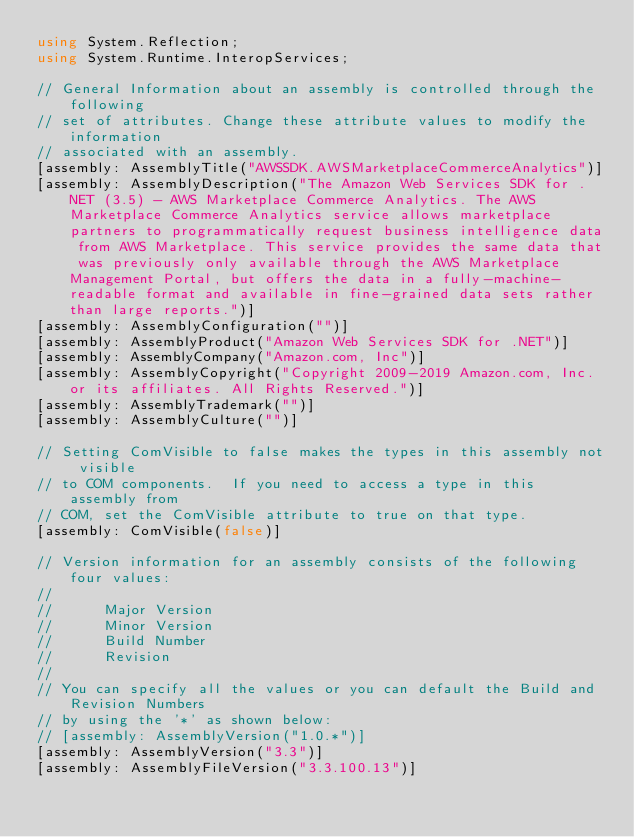<code> <loc_0><loc_0><loc_500><loc_500><_C#_>using System.Reflection;
using System.Runtime.InteropServices;

// General Information about an assembly is controlled through the following 
// set of attributes. Change these attribute values to modify the information
// associated with an assembly.
[assembly: AssemblyTitle("AWSSDK.AWSMarketplaceCommerceAnalytics")]
[assembly: AssemblyDescription("The Amazon Web Services SDK for .NET (3.5) - AWS Marketplace Commerce Analytics. The AWS Marketplace Commerce Analytics service allows marketplace partners to programmatically request business intelligence data from AWS Marketplace. This service provides the same data that was previously only available through the AWS Marketplace Management Portal, but offers the data in a fully-machine-readable format and available in fine-grained data sets rather than large reports.")]
[assembly: AssemblyConfiguration("")]
[assembly: AssemblyProduct("Amazon Web Services SDK for .NET")]
[assembly: AssemblyCompany("Amazon.com, Inc")]
[assembly: AssemblyCopyright("Copyright 2009-2019 Amazon.com, Inc. or its affiliates. All Rights Reserved.")]
[assembly: AssemblyTrademark("")]
[assembly: AssemblyCulture("")]

// Setting ComVisible to false makes the types in this assembly not visible 
// to COM components.  If you need to access a type in this assembly from 
// COM, set the ComVisible attribute to true on that type.
[assembly: ComVisible(false)]

// Version information for an assembly consists of the following four values:
//
//      Major Version
//      Minor Version 
//      Build Number
//      Revision
//
// You can specify all the values or you can default the Build and Revision Numbers 
// by using the '*' as shown below:
// [assembly: AssemblyVersion("1.0.*")]
[assembly: AssemblyVersion("3.3")]
[assembly: AssemblyFileVersion("3.3.100.13")]</code> 